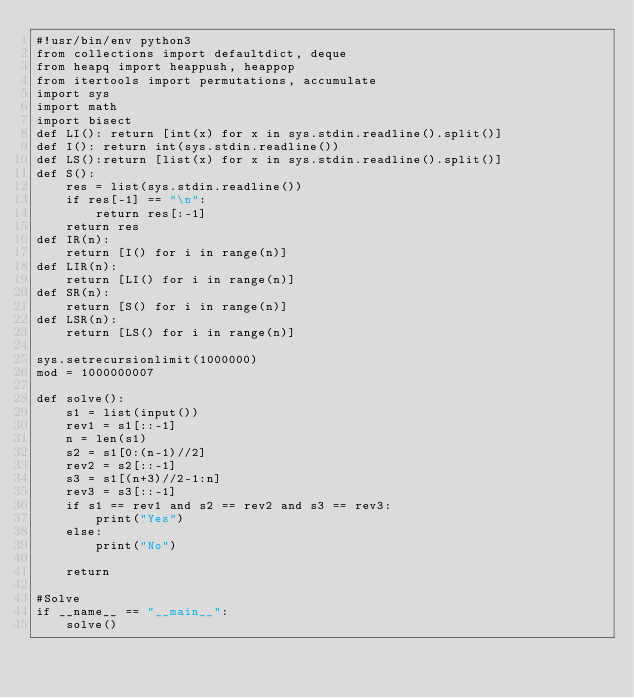Convert code to text. <code><loc_0><loc_0><loc_500><loc_500><_Python_>#!usr/bin/env python3
from collections import defaultdict, deque
from heapq import heappush, heappop
from itertools import permutations, accumulate
import sys
import math
import bisect
def LI(): return [int(x) for x in sys.stdin.readline().split()]
def I(): return int(sys.stdin.readline())
def LS():return [list(x) for x in sys.stdin.readline().split()]
def S():
    res = list(sys.stdin.readline())
    if res[-1] == "\n":
        return res[:-1]
    return res
def IR(n):
    return [I() for i in range(n)]
def LIR(n):
    return [LI() for i in range(n)]
def SR(n):
    return [S() for i in range(n)]
def LSR(n):
    return [LS() for i in range(n)]

sys.setrecursionlimit(1000000)
mod = 1000000007

def solve():
    s1 = list(input())
    rev1 = s1[::-1]
    n = len(s1)
    s2 = s1[0:(n-1)//2]
    rev2 = s2[::-1]
    s3 = s1[(n+3)//2-1:n]
    rev3 = s3[::-1]
    if s1 == rev1 and s2 == rev2 and s3 == rev3:
        print("Yes")
    else:
        print("No")

    return

#Solve
if __name__ == "__main__":
    solve()</code> 